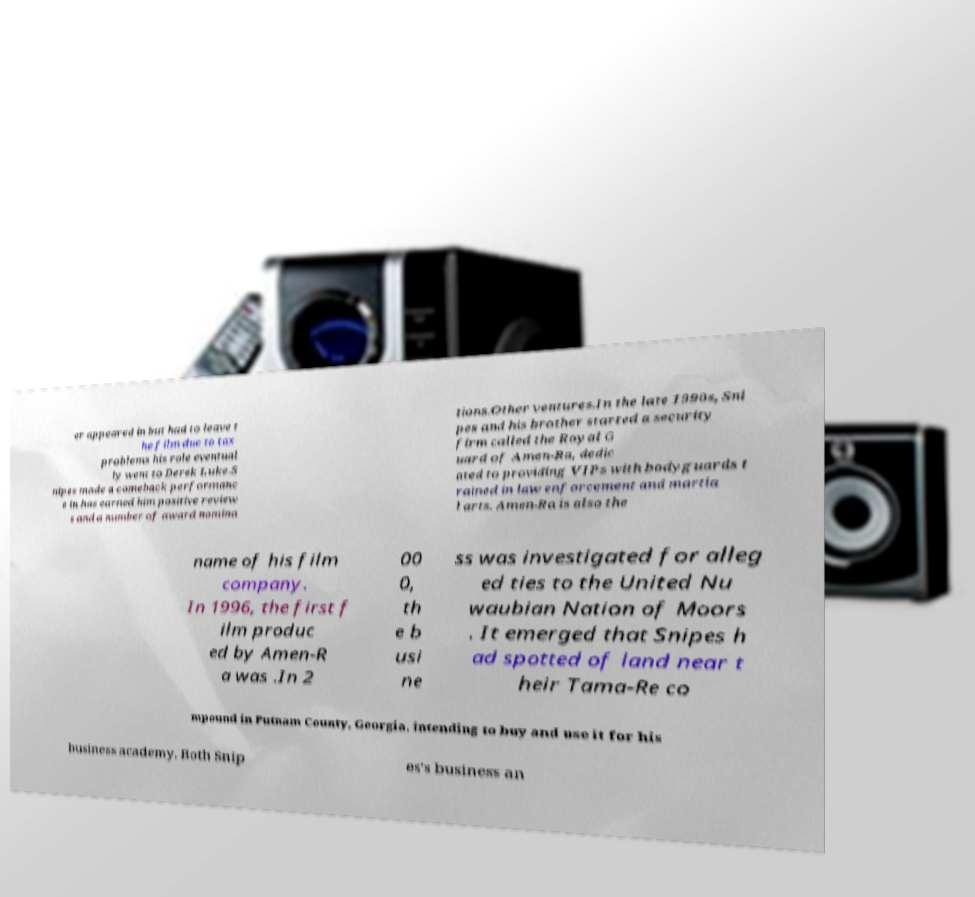There's text embedded in this image that I need extracted. Can you transcribe it verbatim? er appeared in but had to leave t he film due to tax problems his role eventual ly went to Derek Luke.S nipes made a comeback performanc e in has earned him positive review s and a number of award nomina tions.Other ventures.In the late 1990s, Sni pes and his brother started a security firm called the Royal G uard of Amen-Ra, dedic ated to providing VIPs with bodyguards t rained in law enforcement and martia l arts. Amen-Ra is also the name of his film company. In 1996, the first f ilm produc ed by Amen-R a was .In 2 00 0, th e b usi ne ss was investigated for alleg ed ties to the United Nu waubian Nation of Moors . It emerged that Snipes h ad spotted of land near t heir Tama-Re co mpound in Putnam County, Georgia, intending to buy and use it for his business academy. Both Snip es's business an 